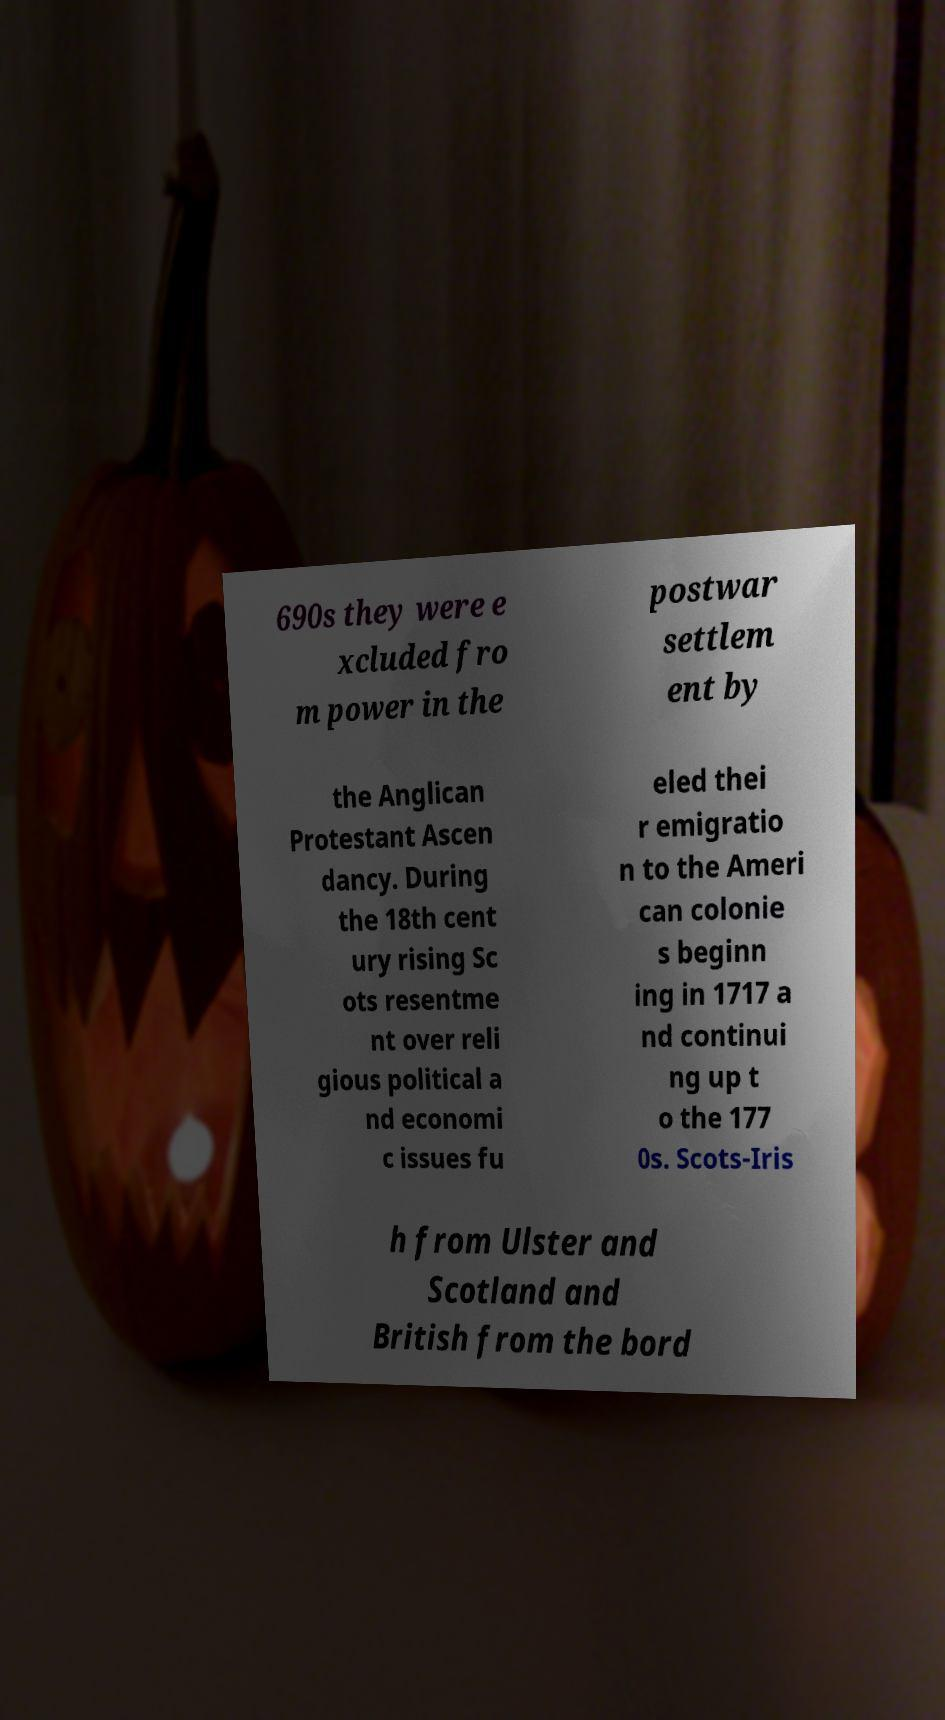Could you assist in decoding the text presented in this image and type it out clearly? 690s they were e xcluded fro m power in the postwar settlem ent by the Anglican Protestant Ascen dancy. During the 18th cent ury rising Sc ots resentme nt over reli gious political a nd economi c issues fu eled thei r emigratio n to the Ameri can colonie s beginn ing in 1717 a nd continui ng up t o the 177 0s. Scots-Iris h from Ulster and Scotland and British from the bord 